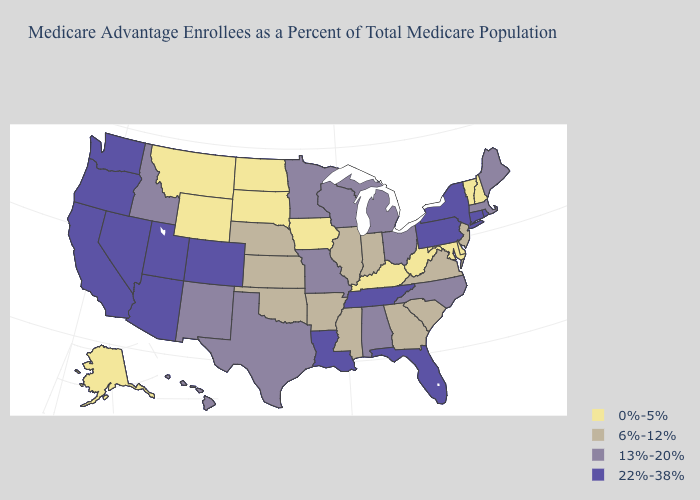What is the value of Virginia?
Be succinct. 6%-12%. What is the highest value in the USA?
Keep it brief. 22%-38%. How many symbols are there in the legend?
Be succinct. 4. Among the states that border Oklahoma , does Texas have the lowest value?
Short answer required. No. How many symbols are there in the legend?
Be succinct. 4. Which states have the lowest value in the Northeast?
Be succinct. New Hampshire, Vermont. What is the value of New York?
Be succinct. 22%-38%. Does Hawaii have the highest value in the West?
Quick response, please. No. Does Louisiana have the highest value in the South?
Short answer required. Yes. What is the value of New Jersey?
Keep it brief. 6%-12%. Among the states that border Maryland , does Pennsylvania have the highest value?
Give a very brief answer. Yes. Does Georgia have a higher value than Wyoming?
Be succinct. Yes. What is the highest value in the Northeast ?
Concise answer only. 22%-38%. What is the highest value in states that border South Carolina?
Write a very short answer. 13%-20%. Name the states that have a value in the range 22%-38%?
Quick response, please. Arizona, California, Colorado, Connecticut, Florida, Louisiana, Nevada, New York, Oregon, Pennsylvania, Rhode Island, Tennessee, Utah, Washington. 